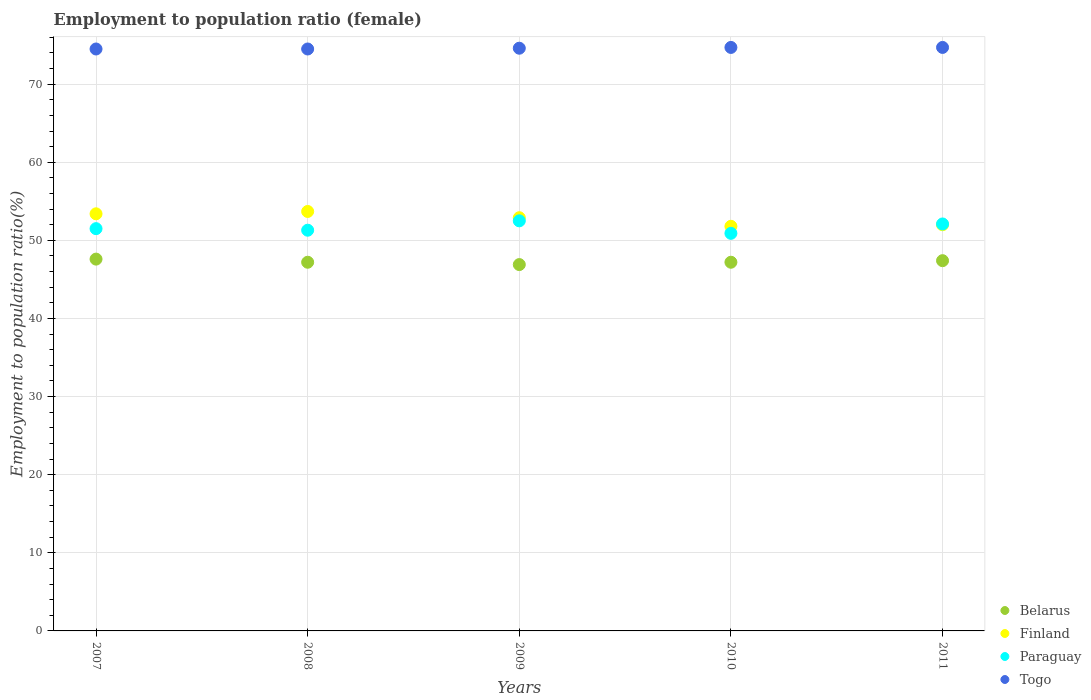Is the number of dotlines equal to the number of legend labels?
Offer a terse response. Yes. What is the employment to population ratio in Belarus in 2007?
Your answer should be compact. 47.6. Across all years, what is the maximum employment to population ratio in Finland?
Provide a short and direct response. 53.7. Across all years, what is the minimum employment to population ratio in Belarus?
Offer a very short reply. 46.9. In which year was the employment to population ratio in Paraguay maximum?
Give a very brief answer. 2009. In which year was the employment to population ratio in Paraguay minimum?
Keep it short and to the point. 2010. What is the total employment to population ratio in Paraguay in the graph?
Offer a terse response. 258.3. What is the difference between the employment to population ratio in Finland in 2007 and that in 2011?
Your answer should be compact. 1.4. What is the difference between the employment to population ratio in Finland in 2011 and the employment to population ratio in Paraguay in 2008?
Your answer should be very brief. 0.7. What is the average employment to population ratio in Finland per year?
Offer a very short reply. 52.76. In the year 2010, what is the difference between the employment to population ratio in Togo and employment to population ratio in Finland?
Offer a terse response. 22.9. In how many years, is the employment to population ratio in Paraguay greater than 20 %?
Provide a succinct answer. 5. What is the ratio of the employment to population ratio in Paraguay in 2007 to that in 2008?
Keep it short and to the point. 1. Is the difference between the employment to population ratio in Togo in 2008 and 2010 greater than the difference between the employment to population ratio in Finland in 2008 and 2010?
Provide a short and direct response. No. What is the difference between the highest and the second highest employment to population ratio in Belarus?
Your response must be concise. 0.2. What is the difference between the highest and the lowest employment to population ratio in Togo?
Your answer should be compact. 0.2. In how many years, is the employment to population ratio in Finland greater than the average employment to population ratio in Finland taken over all years?
Provide a short and direct response. 3. Is the sum of the employment to population ratio in Belarus in 2008 and 2009 greater than the maximum employment to population ratio in Finland across all years?
Provide a short and direct response. Yes. Is it the case that in every year, the sum of the employment to population ratio in Paraguay and employment to population ratio in Togo  is greater than the sum of employment to population ratio in Finland and employment to population ratio in Belarus?
Your answer should be compact. Yes. Is the employment to population ratio in Togo strictly greater than the employment to population ratio in Finland over the years?
Make the answer very short. Yes. How many dotlines are there?
Your answer should be very brief. 4. How many years are there in the graph?
Provide a succinct answer. 5. What is the difference between two consecutive major ticks on the Y-axis?
Provide a succinct answer. 10. Are the values on the major ticks of Y-axis written in scientific E-notation?
Keep it short and to the point. No. Where does the legend appear in the graph?
Provide a succinct answer. Bottom right. What is the title of the graph?
Your response must be concise. Employment to population ratio (female). Does "Greece" appear as one of the legend labels in the graph?
Provide a short and direct response. No. What is the label or title of the X-axis?
Your answer should be compact. Years. What is the Employment to population ratio(%) of Belarus in 2007?
Offer a very short reply. 47.6. What is the Employment to population ratio(%) in Finland in 2007?
Your answer should be compact. 53.4. What is the Employment to population ratio(%) of Paraguay in 2007?
Make the answer very short. 51.5. What is the Employment to population ratio(%) in Togo in 2007?
Ensure brevity in your answer.  74.5. What is the Employment to population ratio(%) of Belarus in 2008?
Your response must be concise. 47.2. What is the Employment to population ratio(%) of Finland in 2008?
Make the answer very short. 53.7. What is the Employment to population ratio(%) in Paraguay in 2008?
Ensure brevity in your answer.  51.3. What is the Employment to population ratio(%) in Togo in 2008?
Provide a short and direct response. 74.5. What is the Employment to population ratio(%) of Belarus in 2009?
Keep it short and to the point. 46.9. What is the Employment to population ratio(%) in Finland in 2009?
Make the answer very short. 52.9. What is the Employment to population ratio(%) in Paraguay in 2009?
Provide a short and direct response. 52.5. What is the Employment to population ratio(%) of Togo in 2009?
Provide a short and direct response. 74.6. What is the Employment to population ratio(%) in Belarus in 2010?
Make the answer very short. 47.2. What is the Employment to population ratio(%) of Finland in 2010?
Your answer should be very brief. 51.8. What is the Employment to population ratio(%) of Paraguay in 2010?
Your response must be concise. 50.9. What is the Employment to population ratio(%) in Togo in 2010?
Give a very brief answer. 74.7. What is the Employment to population ratio(%) of Belarus in 2011?
Your response must be concise. 47.4. What is the Employment to population ratio(%) in Paraguay in 2011?
Provide a succinct answer. 52.1. What is the Employment to population ratio(%) in Togo in 2011?
Provide a short and direct response. 74.7. Across all years, what is the maximum Employment to population ratio(%) in Belarus?
Your answer should be very brief. 47.6. Across all years, what is the maximum Employment to population ratio(%) of Finland?
Offer a very short reply. 53.7. Across all years, what is the maximum Employment to population ratio(%) of Paraguay?
Offer a terse response. 52.5. Across all years, what is the maximum Employment to population ratio(%) in Togo?
Your answer should be compact. 74.7. Across all years, what is the minimum Employment to population ratio(%) in Belarus?
Give a very brief answer. 46.9. Across all years, what is the minimum Employment to population ratio(%) of Finland?
Keep it short and to the point. 51.8. Across all years, what is the minimum Employment to population ratio(%) in Paraguay?
Your answer should be compact. 50.9. Across all years, what is the minimum Employment to population ratio(%) in Togo?
Your answer should be compact. 74.5. What is the total Employment to population ratio(%) of Belarus in the graph?
Provide a succinct answer. 236.3. What is the total Employment to population ratio(%) of Finland in the graph?
Ensure brevity in your answer.  263.8. What is the total Employment to population ratio(%) of Paraguay in the graph?
Make the answer very short. 258.3. What is the total Employment to population ratio(%) of Togo in the graph?
Offer a very short reply. 373. What is the difference between the Employment to population ratio(%) of Finland in 2007 and that in 2008?
Give a very brief answer. -0.3. What is the difference between the Employment to population ratio(%) in Paraguay in 2007 and that in 2008?
Offer a terse response. 0.2. What is the difference between the Employment to population ratio(%) of Belarus in 2007 and that in 2009?
Ensure brevity in your answer.  0.7. What is the difference between the Employment to population ratio(%) of Belarus in 2007 and that in 2010?
Your answer should be compact. 0.4. What is the difference between the Employment to population ratio(%) of Finland in 2007 and that in 2010?
Provide a short and direct response. 1.6. What is the difference between the Employment to population ratio(%) of Paraguay in 2007 and that in 2010?
Keep it short and to the point. 0.6. What is the difference between the Employment to population ratio(%) in Belarus in 2008 and that in 2010?
Provide a short and direct response. 0. What is the difference between the Employment to population ratio(%) of Finland in 2008 and that in 2010?
Your response must be concise. 1.9. What is the difference between the Employment to population ratio(%) in Togo in 2008 and that in 2010?
Keep it short and to the point. -0.2. What is the difference between the Employment to population ratio(%) of Belarus in 2008 and that in 2011?
Offer a very short reply. -0.2. What is the difference between the Employment to population ratio(%) of Finland in 2008 and that in 2011?
Offer a terse response. 1.7. What is the difference between the Employment to population ratio(%) of Paraguay in 2008 and that in 2011?
Provide a short and direct response. -0.8. What is the difference between the Employment to population ratio(%) of Finland in 2009 and that in 2010?
Make the answer very short. 1.1. What is the difference between the Employment to population ratio(%) of Belarus in 2009 and that in 2011?
Provide a succinct answer. -0.5. What is the difference between the Employment to population ratio(%) in Finland in 2009 and that in 2011?
Make the answer very short. 0.9. What is the difference between the Employment to population ratio(%) in Paraguay in 2009 and that in 2011?
Ensure brevity in your answer.  0.4. What is the difference between the Employment to population ratio(%) in Togo in 2009 and that in 2011?
Make the answer very short. -0.1. What is the difference between the Employment to population ratio(%) of Belarus in 2010 and that in 2011?
Offer a terse response. -0.2. What is the difference between the Employment to population ratio(%) of Paraguay in 2010 and that in 2011?
Provide a succinct answer. -1.2. What is the difference between the Employment to population ratio(%) in Togo in 2010 and that in 2011?
Provide a short and direct response. 0. What is the difference between the Employment to population ratio(%) of Belarus in 2007 and the Employment to population ratio(%) of Paraguay in 2008?
Provide a short and direct response. -3.7. What is the difference between the Employment to population ratio(%) of Belarus in 2007 and the Employment to population ratio(%) of Togo in 2008?
Provide a succinct answer. -26.9. What is the difference between the Employment to population ratio(%) in Finland in 2007 and the Employment to population ratio(%) in Paraguay in 2008?
Give a very brief answer. 2.1. What is the difference between the Employment to population ratio(%) of Finland in 2007 and the Employment to population ratio(%) of Togo in 2008?
Offer a very short reply. -21.1. What is the difference between the Employment to population ratio(%) of Paraguay in 2007 and the Employment to population ratio(%) of Togo in 2008?
Ensure brevity in your answer.  -23. What is the difference between the Employment to population ratio(%) of Belarus in 2007 and the Employment to population ratio(%) of Finland in 2009?
Offer a terse response. -5.3. What is the difference between the Employment to population ratio(%) of Belarus in 2007 and the Employment to population ratio(%) of Togo in 2009?
Make the answer very short. -27. What is the difference between the Employment to population ratio(%) in Finland in 2007 and the Employment to population ratio(%) in Paraguay in 2009?
Keep it short and to the point. 0.9. What is the difference between the Employment to population ratio(%) of Finland in 2007 and the Employment to population ratio(%) of Togo in 2009?
Keep it short and to the point. -21.2. What is the difference between the Employment to population ratio(%) in Paraguay in 2007 and the Employment to population ratio(%) in Togo in 2009?
Give a very brief answer. -23.1. What is the difference between the Employment to population ratio(%) of Belarus in 2007 and the Employment to population ratio(%) of Togo in 2010?
Your response must be concise. -27.1. What is the difference between the Employment to population ratio(%) of Finland in 2007 and the Employment to population ratio(%) of Togo in 2010?
Your response must be concise. -21.3. What is the difference between the Employment to population ratio(%) in Paraguay in 2007 and the Employment to population ratio(%) in Togo in 2010?
Provide a succinct answer. -23.2. What is the difference between the Employment to population ratio(%) of Belarus in 2007 and the Employment to population ratio(%) of Paraguay in 2011?
Make the answer very short. -4.5. What is the difference between the Employment to population ratio(%) in Belarus in 2007 and the Employment to population ratio(%) in Togo in 2011?
Provide a short and direct response. -27.1. What is the difference between the Employment to population ratio(%) of Finland in 2007 and the Employment to population ratio(%) of Paraguay in 2011?
Provide a short and direct response. 1.3. What is the difference between the Employment to population ratio(%) in Finland in 2007 and the Employment to population ratio(%) in Togo in 2011?
Provide a succinct answer. -21.3. What is the difference between the Employment to population ratio(%) in Paraguay in 2007 and the Employment to population ratio(%) in Togo in 2011?
Provide a succinct answer. -23.2. What is the difference between the Employment to population ratio(%) of Belarus in 2008 and the Employment to population ratio(%) of Togo in 2009?
Your response must be concise. -27.4. What is the difference between the Employment to population ratio(%) in Finland in 2008 and the Employment to population ratio(%) in Togo in 2009?
Your response must be concise. -20.9. What is the difference between the Employment to population ratio(%) of Paraguay in 2008 and the Employment to population ratio(%) of Togo in 2009?
Provide a short and direct response. -23.3. What is the difference between the Employment to population ratio(%) of Belarus in 2008 and the Employment to population ratio(%) of Finland in 2010?
Offer a very short reply. -4.6. What is the difference between the Employment to population ratio(%) of Belarus in 2008 and the Employment to population ratio(%) of Paraguay in 2010?
Keep it short and to the point. -3.7. What is the difference between the Employment to population ratio(%) of Belarus in 2008 and the Employment to population ratio(%) of Togo in 2010?
Ensure brevity in your answer.  -27.5. What is the difference between the Employment to population ratio(%) in Finland in 2008 and the Employment to population ratio(%) in Togo in 2010?
Your response must be concise. -21. What is the difference between the Employment to population ratio(%) of Paraguay in 2008 and the Employment to population ratio(%) of Togo in 2010?
Your response must be concise. -23.4. What is the difference between the Employment to population ratio(%) in Belarus in 2008 and the Employment to population ratio(%) in Finland in 2011?
Provide a short and direct response. -4.8. What is the difference between the Employment to population ratio(%) in Belarus in 2008 and the Employment to population ratio(%) in Paraguay in 2011?
Provide a short and direct response. -4.9. What is the difference between the Employment to population ratio(%) of Belarus in 2008 and the Employment to population ratio(%) of Togo in 2011?
Make the answer very short. -27.5. What is the difference between the Employment to population ratio(%) of Paraguay in 2008 and the Employment to population ratio(%) of Togo in 2011?
Give a very brief answer. -23.4. What is the difference between the Employment to population ratio(%) in Belarus in 2009 and the Employment to population ratio(%) in Paraguay in 2010?
Make the answer very short. -4. What is the difference between the Employment to population ratio(%) in Belarus in 2009 and the Employment to population ratio(%) in Togo in 2010?
Provide a short and direct response. -27.8. What is the difference between the Employment to population ratio(%) in Finland in 2009 and the Employment to population ratio(%) in Togo in 2010?
Offer a very short reply. -21.8. What is the difference between the Employment to population ratio(%) of Paraguay in 2009 and the Employment to population ratio(%) of Togo in 2010?
Your answer should be very brief. -22.2. What is the difference between the Employment to population ratio(%) in Belarus in 2009 and the Employment to population ratio(%) in Togo in 2011?
Give a very brief answer. -27.8. What is the difference between the Employment to population ratio(%) of Finland in 2009 and the Employment to population ratio(%) of Togo in 2011?
Provide a short and direct response. -21.8. What is the difference between the Employment to population ratio(%) of Paraguay in 2009 and the Employment to population ratio(%) of Togo in 2011?
Provide a succinct answer. -22.2. What is the difference between the Employment to population ratio(%) in Belarus in 2010 and the Employment to population ratio(%) in Paraguay in 2011?
Offer a terse response. -4.9. What is the difference between the Employment to population ratio(%) in Belarus in 2010 and the Employment to population ratio(%) in Togo in 2011?
Provide a short and direct response. -27.5. What is the difference between the Employment to population ratio(%) in Finland in 2010 and the Employment to population ratio(%) in Togo in 2011?
Provide a succinct answer. -22.9. What is the difference between the Employment to population ratio(%) of Paraguay in 2010 and the Employment to population ratio(%) of Togo in 2011?
Keep it short and to the point. -23.8. What is the average Employment to population ratio(%) of Belarus per year?
Provide a short and direct response. 47.26. What is the average Employment to population ratio(%) in Finland per year?
Offer a very short reply. 52.76. What is the average Employment to population ratio(%) of Paraguay per year?
Make the answer very short. 51.66. What is the average Employment to population ratio(%) in Togo per year?
Keep it short and to the point. 74.6. In the year 2007, what is the difference between the Employment to population ratio(%) of Belarus and Employment to population ratio(%) of Togo?
Make the answer very short. -26.9. In the year 2007, what is the difference between the Employment to population ratio(%) in Finland and Employment to population ratio(%) in Togo?
Ensure brevity in your answer.  -21.1. In the year 2007, what is the difference between the Employment to population ratio(%) of Paraguay and Employment to population ratio(%) of Togo?
Provide a succinct answer. -23. In the year 2008, what is the difference between the Employment to population ratio(%) in Belarus and Employment to population ratio(%) in Paraguay?
Give a very brief answer. -4.1. In the year 2008, what is the difference between the Employment to population ratio(%) in Belarus and Employment to population ratio(%) in Togo?
Provide a short and direct response. -27.3. In the year 2008, what is the difference between the Employment to population ratio(%) in Finland and Employment to population ratio(%) in Paraguay?
Your answer should be very brief. 2.4. In the year 2008, what is the difference between the Employment to population ratio(%) of Finland and Employment to population ratio(%) of Togo?
Give a very brief answer. -20.8. In the year 2008, what is the difference between the Employment to population ratio(%) in Paraguay and Employment to population ratio(%) in Togo?
Give a very brief answer. -23.2. In the year 2009, what is the difference between the Employment to population ratio(%) in Belarus and Employment to population ratio(%) in Togo?
Provide a succinct answer. -27.7. In the year 2009, what is the difference between the Employment to population ratio(%) of Finland and Employment to population ratio(%) of Togo?
Your response must be concise. -21.7. In the year 2009, what is the difference between the Employment to population ratio(%) in Paraguay and Employment to population ratio(%) in Togo?
Offer a terse response. -22.1. In the year 2010, what is the difference between the Employment to population ratio(%) in Belarus and Employment to population ratio(%) in Togo?
Provide a succinct answer. -27.5. In the year 2010, what is the difference between the Employment to population ratio(%) of Finland and Employment to population ratio(%) of Paraguay?
Give a very brief answer. 0.9. In the year 2010, what is the difference between the Employment to population ratio(%) of Finland and Employment to population ratio(%) of Togo?
Your answer should be very brief. -22.9. In the year 2010, what is the difference between the Employment to population ratio(%) in Paraguay and Employment to population ratio(%) in Togo?
Keep it short and to the point. -23.8. In the year 2011, what is the difference between the Employment to population ratio(%) in Belarus and Employment to population ratio(%) in Finland?
Ensure brevity in your answer.  -4.6. In the year 2011, what is the difference between the Employment to population ratio(%) of Belarus and Employment to population ratio(%) of Togo?
Offer a terse response. -27.3. In the year 2011, what is the difference between the Employment to population ratio(%) of Finland and Employment to population ratio(%) of Paraguay?
Offer a very short reply. -0.1. In the year 2011, what is the difference between the Employment to population ratio(%) in Finland and Employment to population ratio(%) in Togo?
Provide a short and direct response. -22.7. In the year 2011, what is the difference between the Employment to population ratio(%) of Paraguay and Employment to population ratio(%) of Togo?
Your response must be concise. -22.6. What is the ratio of the Employment to population ratio(%) in Belarus in 2007 to that in 2008?
Keep it short and to the point. 1.01. What is the ratio of the Employment to population ratio(%) in Finland in 2007 to that in 2008?
Give a very brief answer. 0.99. What is the ratio of the Employment to population ratio(%) of Togo in 2007 to that in 2008?
Your answer should be compact. 1. What is the ratio of the Employment to population ratio(%) in Belarus in 2007 to that in 2009?
Offer a terse response. 1.01. What is the ratio of the Employment to population ratio(%) of Finland in 2007 to that in 2009?
Provide a short and direct response. 1.01. What is the ratio of the Employment to population ratio(%) of Paraguay in 2007 to that in 2009?
Give a very brief answer. 0.98. What is the ratio of the Employment to population ratio(%) of Belarus in 2007 to that in 2010?
Your response must be concise. 1.01. What is the ratio of the Employment to population ratio(%) of Finland in 2007 to that in 2010?
Ensure brevity in your answer.  1.03. What is the ratio of the Employment to population ratio(%) of Paraguay in 2007 to that in 2010?
Make the answer very short. 1.01. What is the ratio of the Employment to population ratio(%) of Finland in 2007 to that in 2011?
Your answer should be compact. 1.03. What is the ratio of the Employment to population ratio(%) in Paraguay in 2007 to that in 2011?
Ensure brevity in your answer.  0.99. What is the ratio of the Employment to population ratio(%) in Togo in 2007 to that in 2011?
Provide a succinct answer. 1. What is the ratio of the Employment to population ratio(%) of Belarus in 2008 to that in 2009?
Ensure brevity in your answer.  1.01. What is the ratio of the Employment to population ratio(%) in Finland in 2008 to that in 2009?
Keep it short and to the point. 1.02. What is the ratio of the Employment to population ratio(%) of Paraguay in 2008 to that in 2009?
Offer a very short reply. 0.98. What is the ratio of the Employment to population ratio(%) in Togo in 2008 to that in 2009?
Your response must be concise. 1. What is the ratio of the Employment to population ratio(%) in Belarus in 2008 to that in 2010?
Your answer should be very brief. 1. What is the ratio of the Employment to population ratio(%) in Finland in 2008 to that in 2010?
Your response must be concise. 1.04. What is the ratio of the Employment to population ratio(%) of Paraguay in 2008 to that in 2010?
Offer a terse response. 1.01. What is the ratio of the Employment to population ratio(%) in Belarus in 2008 to that in 2011?
Provide a succinct answer. 1. What is the ratio of the Employment to population ratio(%) of Finland in 2008 to that in 2011?
Provide a short and direct response. 1.03. What is the ratio of the Employment to population ratio(%) in Paraguay in 2008 to that in 2011?
Your answer should be very brief. 0.98. What is the ratio of the Employment to population ratio(%) in Belarus in 2009 to that in 2010?
Provide a succinct answer. 0.99. What is the ratio of the Employment to population ratio(%) in Finland in 2009 to that in 2010?
Provide a short and direct response. 1.02. What is the ratio of the Employment to population ratio(%) of Paraguay in 2009 to that in 2010?
Offer a terse response. 1.03. What is the ratio of the Employment to population ratio(%) in Belarus in 2009 to that in 2011?
Your response must be concise. 0.99. What is the ratio of the Employment to population ratio(%) in Finland in 2009 to that in 2011?
Your answer should be compact. 1.02. What is the ratio of the Employment to population ratio(%) in Paraguay in 2009 to that in 2011?
Ensure brevity in your answer.  1.01. What is the ratio of the Employment to population ratio(%) in Togo in 2009 to that in 2011?
Ensure brevity in your answer.  1. What is the ratio of the Employment to population ratio(%) of Finland in 2010 to that in 2011?
Give a very brief answer. 1. What is the ratio of the Employment to population ratio(%) in Paraguay in 2010 to that in 2011?
Make the answer very short. 0.98. What is the difference between the highest and the second highest Employment to population ratio(%) of Togo?
Keep it short and to the point. 0. What is the difference between the highest and the lowest Employment to population ratio(%) of Belarus?
Ensure brevity in your answer.  0.7. What is the difference between the highest and the lowest Employment to population ratio(%) of Paraguay?
Your answer should be compact. 1.6. What is the difference between the highest and the lowest Employment to population ratio(%) in Togo?
Ensure brevity in your answer.  0.2. 